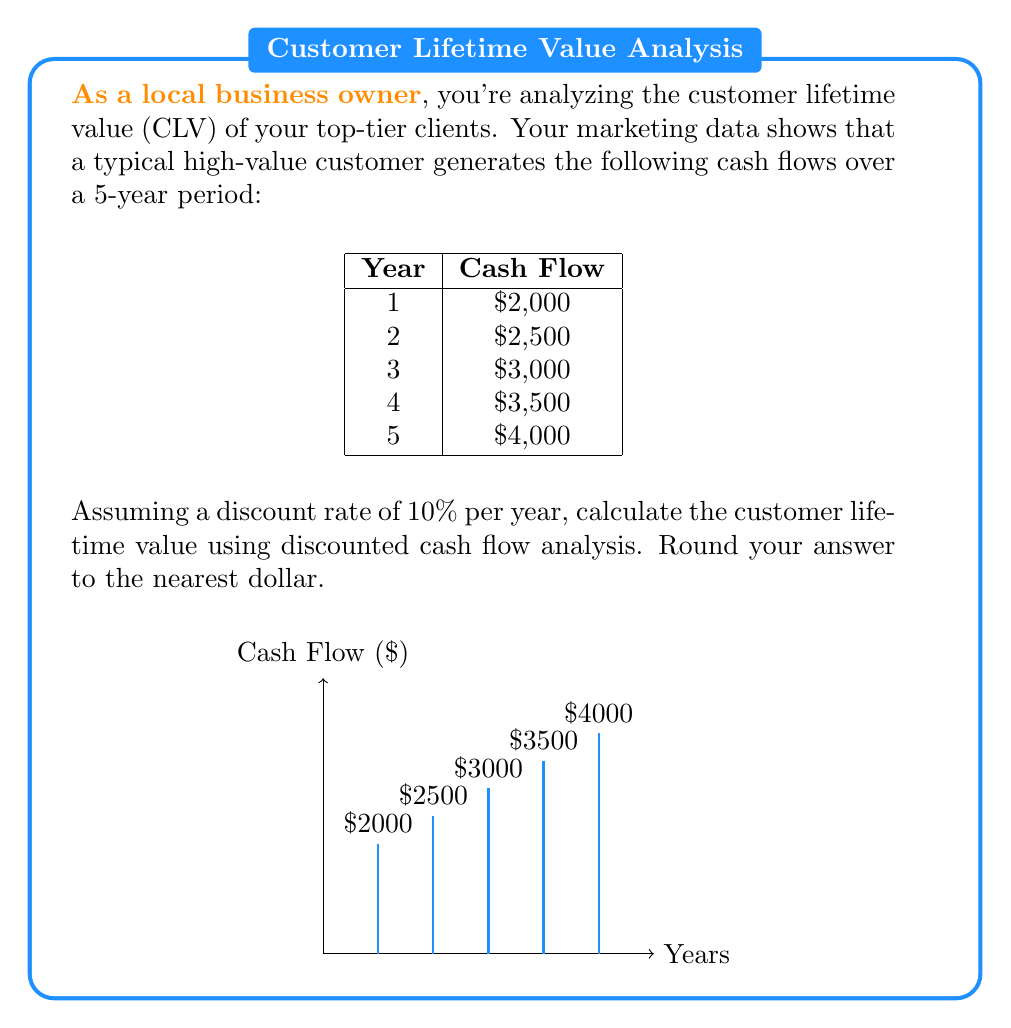Show me your answer to this math problem. To calculate the customer lifetime value using discounted cash flow analysis, we need to follow these steps:

1) The formula for discounted cash flow is:
   $$ DCF = \sum_{t=1}^{n} \frac{CF_t}{(1+r)^t} $$
   where $CF_t$ is the cash flow at time $t$, $r$ is the discount rate, and $n$ is the number of periods.

2) Let's calculate the present value of each year's cash flow:

   Year 1: $\frac{2000}{(1+0.1)^1} = \frac{2000}{1.1} = 1818.18$

   Year 2: $\frac{2500}{(1+0.1)^2} = \frac{2500}{1.21} = 2066.12$

   Year 3: $\frac{3000}{(1+0.1)^3} = \frac{3000}{1.331} = 2254.70$

   Year 4: $\frac{3500}{(1+0.1)^4} = \frac{3500}{1.4641} = 2390.41$

   Year 5: $\frac{4000}{(1+0.1)^5} = \frac{4000}{1.61051} = 2483.71$

3) Sum up all the discounted cash flows:

   $CLV = 1818.18 + 2066.12 + 2254.70 + 2390.41 + 2483.71 = 11013.12$

4) Rounding to the nearest dollar:

   $CLV ≈ 11013$

Therefore, the customer lifetime value is approximately $11,013.
Answer: $11,013 